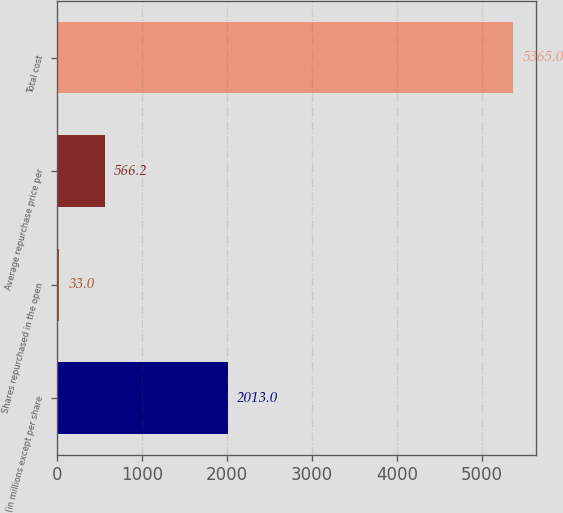<chart> <loc_0><loc_0><loc_500><loc_500><bar_chart><fcel>(in millions except per share<fcel>Shares repurchased in the open<fcel>Average repurchase price per<fcel>Total cost<nl><fcel>2013<fcel>33<fcel>566.2<fcel>5365<nl></chart> 